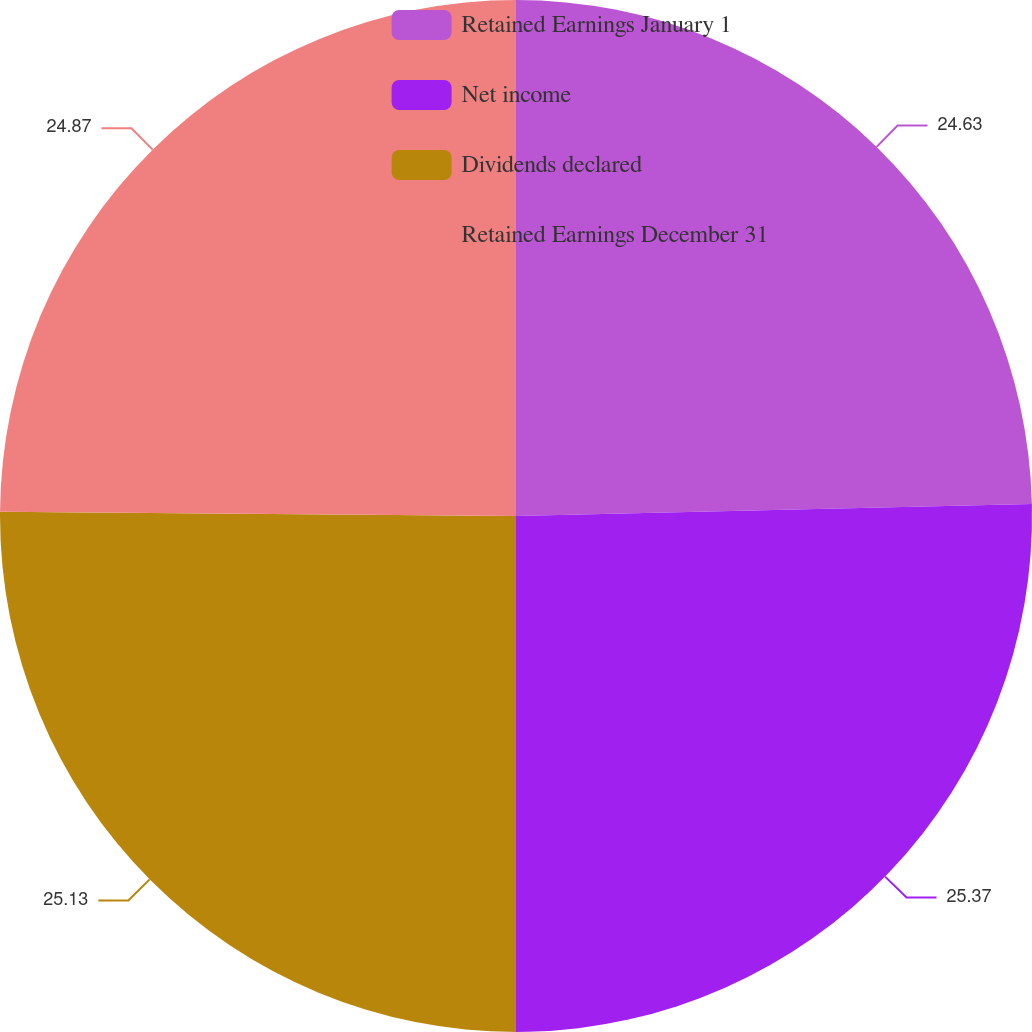Convert chart. <chart><loc_0><loc_0><loc_500><loc_500><pie_chart><fcel>Retained Earnings January 1<fcel>Net income<fcel>Dividends declared<fcel>Retained Earnings December 31<nl><fcel>24.63%<fcel>25.37%<fcel>25.13%<fcel>24.87%<nl></chart> 